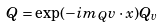<formula> <loc_0><loc_0><loc_500><loc_500>Q = \exp ( - i m _ { Q } v \cdot x ) Q _ { v }</formula> 